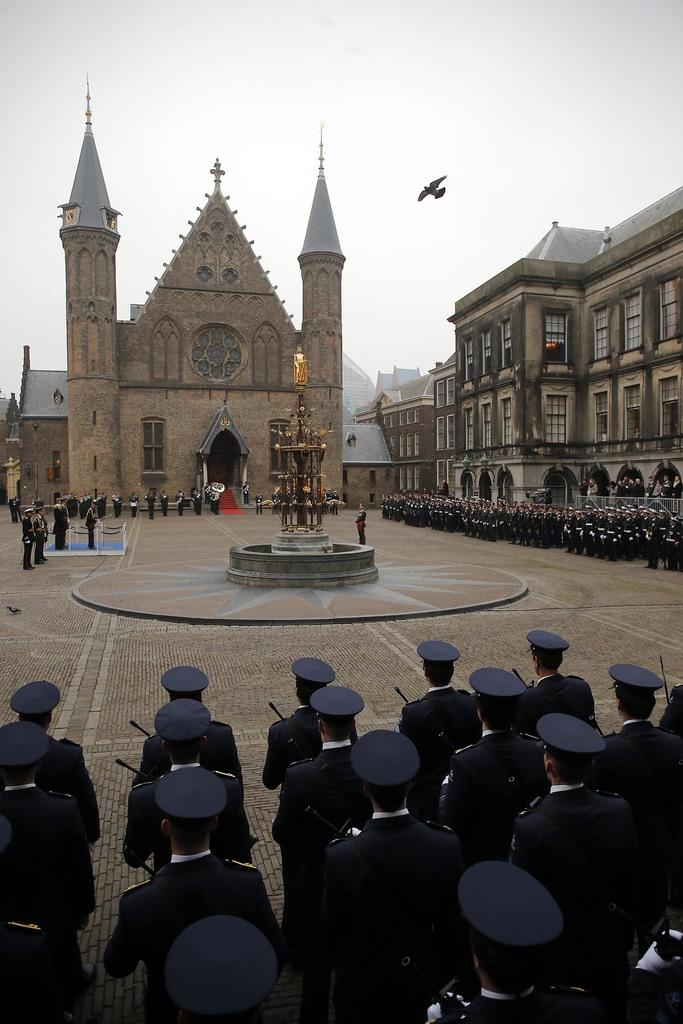What type of structures are present in the image? There are buildings in the image. What feature do the buildings have? The buildings have windows. Who is in front of the buildings? There are people in front of the buildings. What are the people wearing? The people are wearing uniforms and caps. What type of prose can be seen on the walls of the buildings in the image? There is no prose visible on the walls of the buildings in the image. Is there any smoke coming from the buildings in the image? There is no smoke present in the image. 